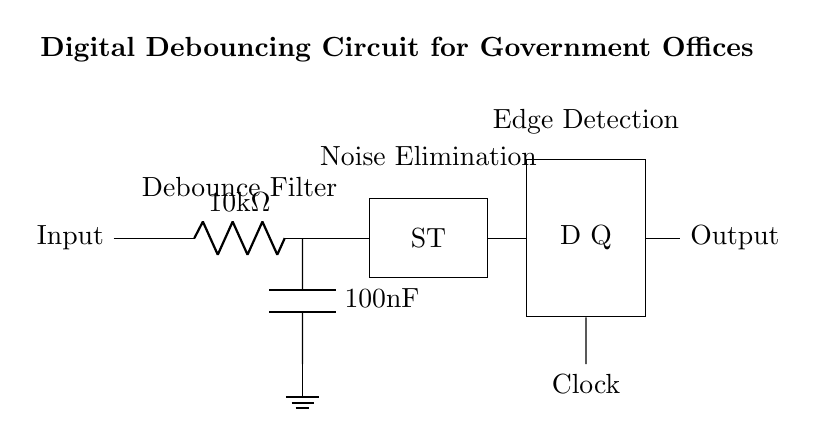What component is used to filter out noise? The RC filter is indicated by a resistor and capacitor in series, which smooths out rapid fluctuations in input signals, effectively filtering noise.
Answer: RC filter What is the value of the resistor in the RC filter? The resistor value is specified directly in the diagram as 10 kiloOhms, which is typical for debouncing applications to provide a smooth signal.
Answer: 10 kiloOhms What does the Schmitt Trigger do in this circuit? The Schmitt Trigger converts the noisy signal from the RC filter into a clean digital signal by utilizing hysteresis, meaning it triggers at different voltage levels for rising and falling edges, effectively preventing multiple transitions due to noise.
Answer: Noise elimination How does the D Flip-Flop contribute to the circuit's functionality? The D Flip-Flop captures the output of the Schmitt Trigger at the clock edge and maintains that state stable until the next clock pulse, ensuring the output is only updated on definitive changes, thus eliminating bouncing effects.
Answer: Edge detection What role does the capacitor play in the RC filter? The capacitor charges and discharges, smoothing the input voltage by integrating it over time, which helps to reduce high-frequency noise components in the signal before it reaches the Schmitt Trigger.
Answer: Smoothing 